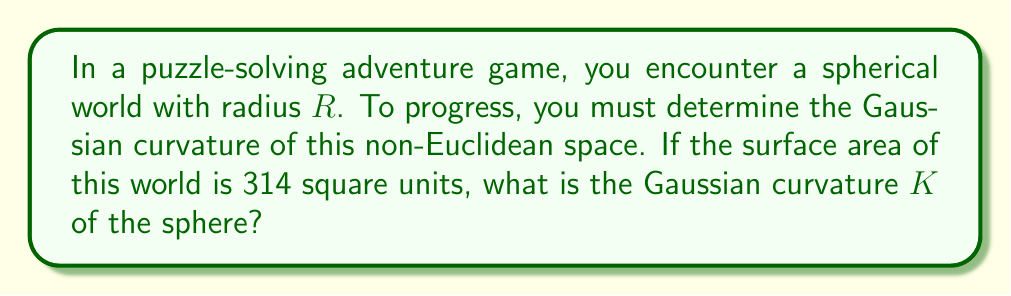Could you help me with this problem? Let's approach this step-by-step:

1) The Gaussian curvature $K$ of a sphere is constant and given by:

   $$K = \frac{1}{R^2}$$

   where $R$ is the radius of the sphere.

2) We need to find $R$ first. We can do this using the surface area formula for a sphere:

   $$A = 4\pi R^2$$

3) We're given that the surface area $A = 314$ square units. Let's substitute this:

   $$314 = 4\pi R^2$$

4) Solve for $R$:

   $$R^2 = \frac{314}{4\pi}$$
   $$R = \sqrt{\frac{314}{4\pi}} \approx 5$$

5) Now that we have $R$, we can calculate $K$:

   $$K = \frac{1}{R^2} = \frac{1}{(\sqrt{\frac{314}{4\pi}})^2} = \frac{4\pi}{314}$$

6) Simplify:

   $$K = \frac{\pi}{78.5} \approx 0.04$$

Thus, the Gaussian curvature of the spherical world is $\frac{\pi}{78.5}$ or approximately 0.04 per square unit.
Answer: $\frac{\pi}{78.5}$ 